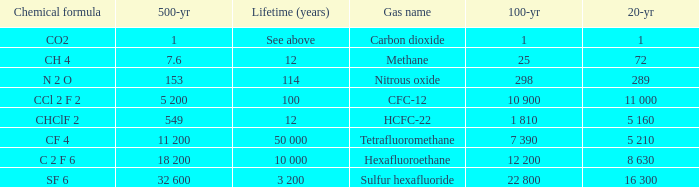What is the 20 year for Nitrous Oxide? 289.0. 